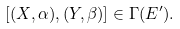<formula> <loc_0><loc_0><loc_500><loc_500>[ ( X , \alpha ) , ( Y , \beta ) ] \in \Gamma ( E ^ { \prime } ) .</formula> 